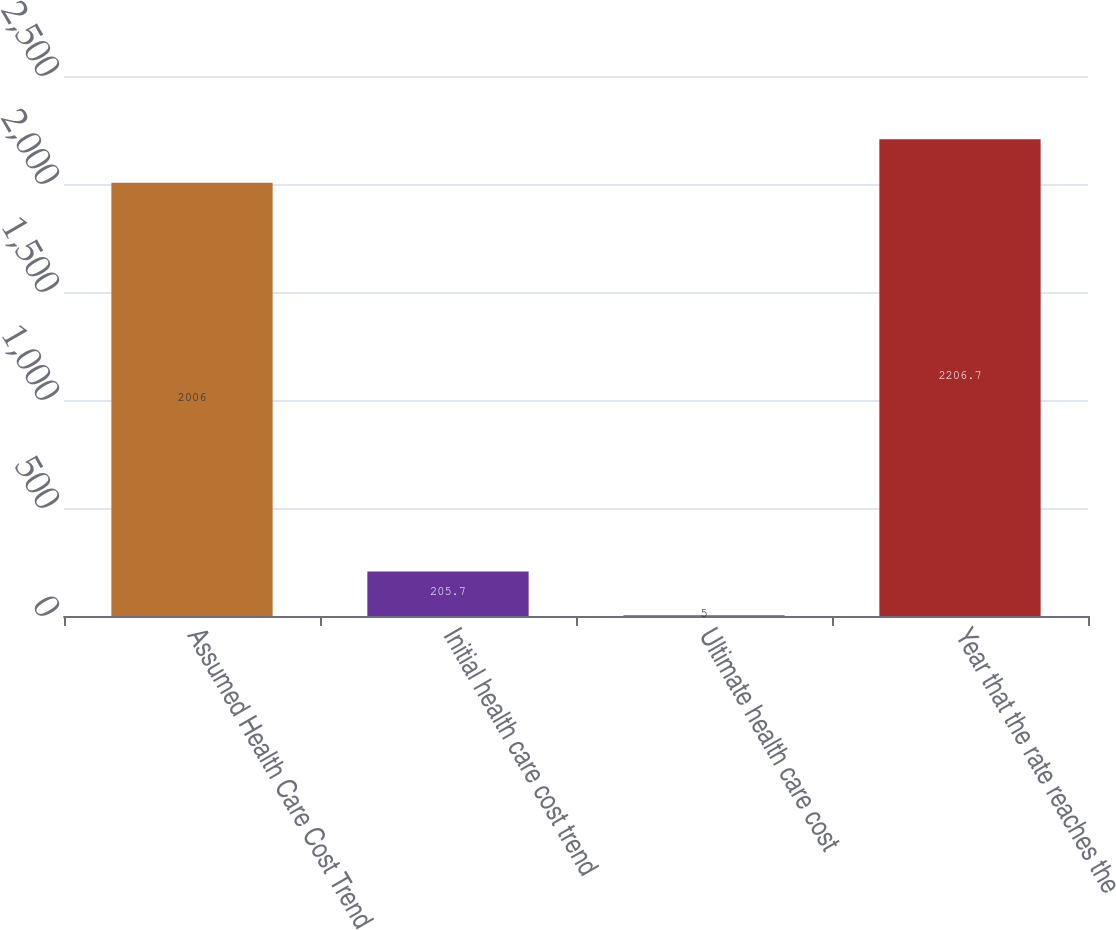Convert chart. <chart><loc_0><loc_0><loc_500><loc_500><bar_chart><fcel>Assumed Health Care Cost Trend<fcel>Initial health care cost trend<fcel>Ultimate health care cost<fcel>Year that the rate reaches the<nl><fcel>2006<fcel>205.7<fcel>5<fcel>2206.7<nl></chart> 